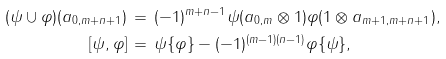<formula> <loc_0><loc_0><loc_500><loc_500>( \psi \cup \varphi ) ( a _ { 0 , m + n + 1 } ) & \, = \, ( - 1 ) ^ { m + n - 1 } \psi ( a _ { 0 , m } \otimes 1 ) \varphi ( 1 \otimes a _ { m + 1 , m + n + 1 } ) , \\ [ \psi , \varphi ] & \, = \, \psi \{ \varphi \} - ( - 1 ) ^ { ( m - 1 ) ( n - 1 ) } \varphi \{ \psi \} ,</formula> 